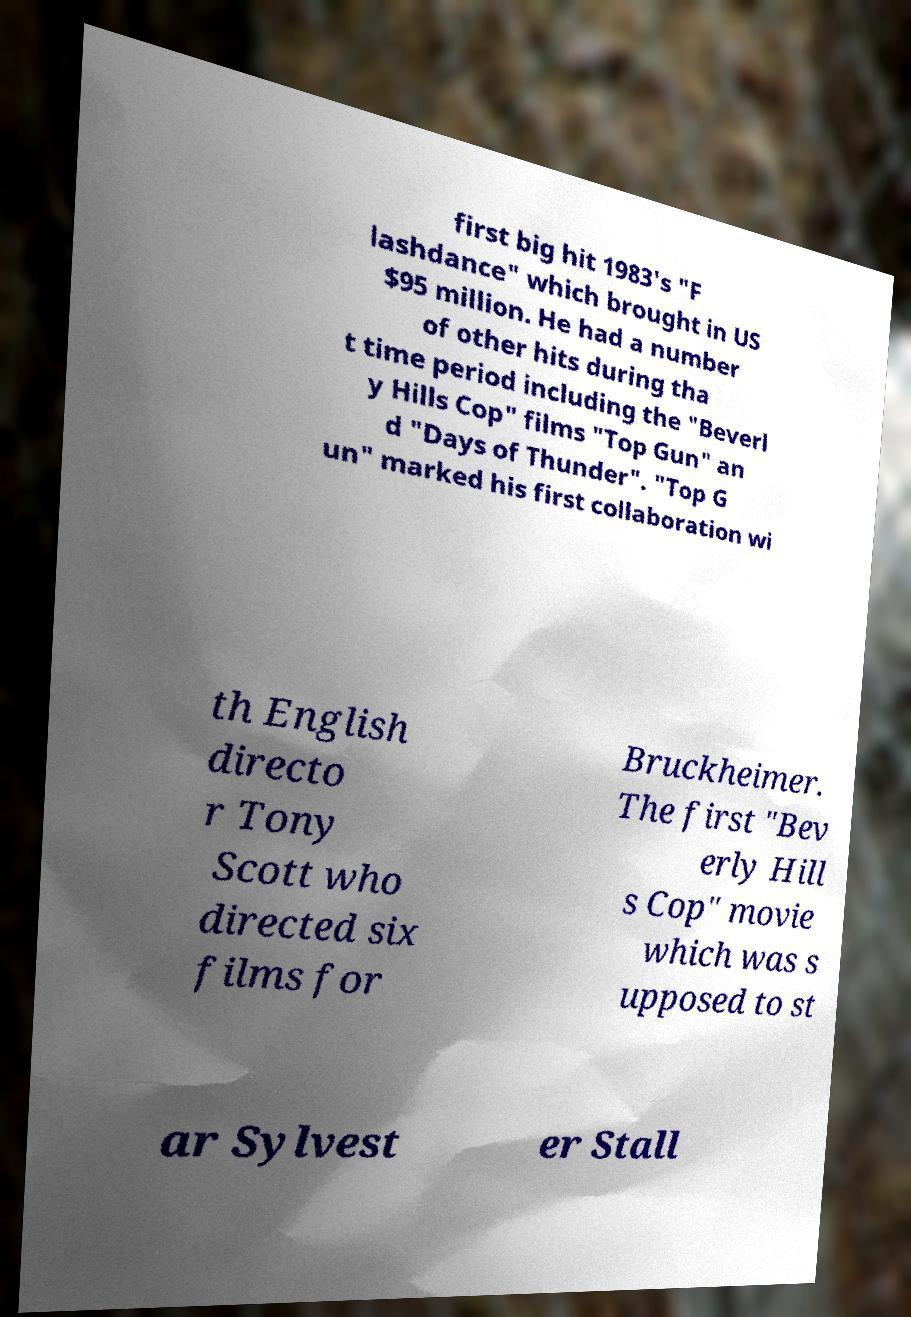Please read and relay the text visible in this image. What does it say? first big hit 1983's "F lashdance" which brought in US $95 million. He had a number of other hits during tha t time period including the "Beverl y Hills Cop" films "Top Gun" an d "Days of Thunder". "Top G un" marked his first collaboration wi th English directo r Tony Scott who directed six films for Bruckheimer. The first "Bev erly Hill s Cop" movie which was s upposed to st ar Sylvest er Stall 